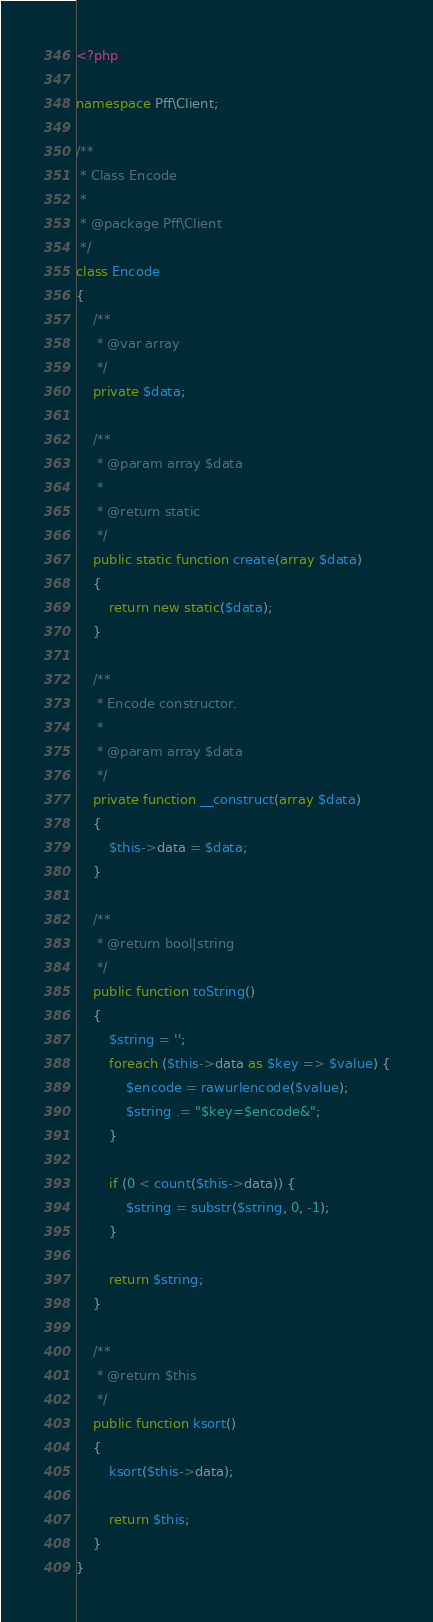Convert code to text. <code><loc_0><loc_0><loc_500><loc_500><_PHP_><?php

namespace Pff\Client;

/**
 * Class Encode
 *
 * @package Pff\Client
 */
class Encode
{
    /**
     * @var array
     */
    private $data;

    /**
     * @param array $data
     *
     * @return static
     */
    public static function create(array $data)
    {
        return new static($data);
    }

    /**
     * Encode constructor.
     *
     * @param array $data
     */
    private function __construct(array $data)
    {
        $this->data = $data;
    }

    /**
     * @return bool|string
     */
    public function toString()
    {
        $string = '';
        foreach ($this->data as $key => $value) {
            $encode = rawurlencode($value);
            $string .= "$key=$encode&";
        }

        if (0 < count($this->data)) {
            $string = substr($string, 0, -1);
        }

        return $string;
    }

    /**
     * @return $this
     */
    public function ksort()
    {
        ksort($this->data);

        return $this;
    }
}
</code> 